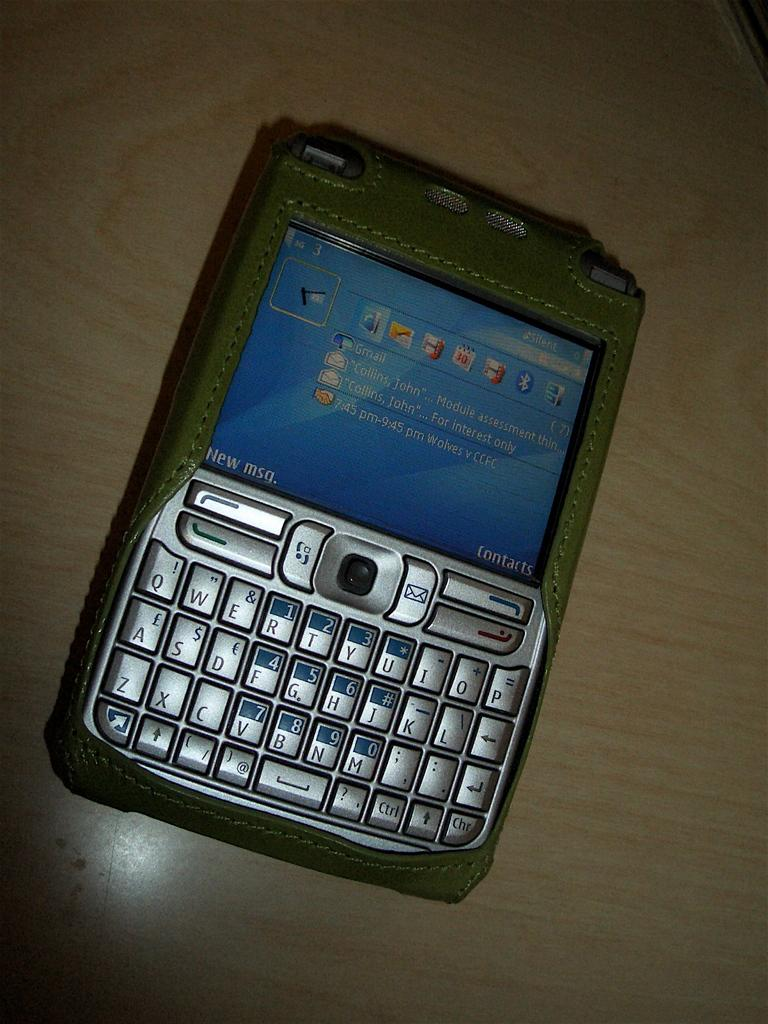<image>
Summarize the visual content of the image. A user's Gmail account is visible on their cell phone screen. 